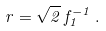<formula> <loc_0><loc_0><loc_500><loc_500>r = \sqrt { 2 } \, f _ { 1 } ^ { - 1 } \, .</formula> 